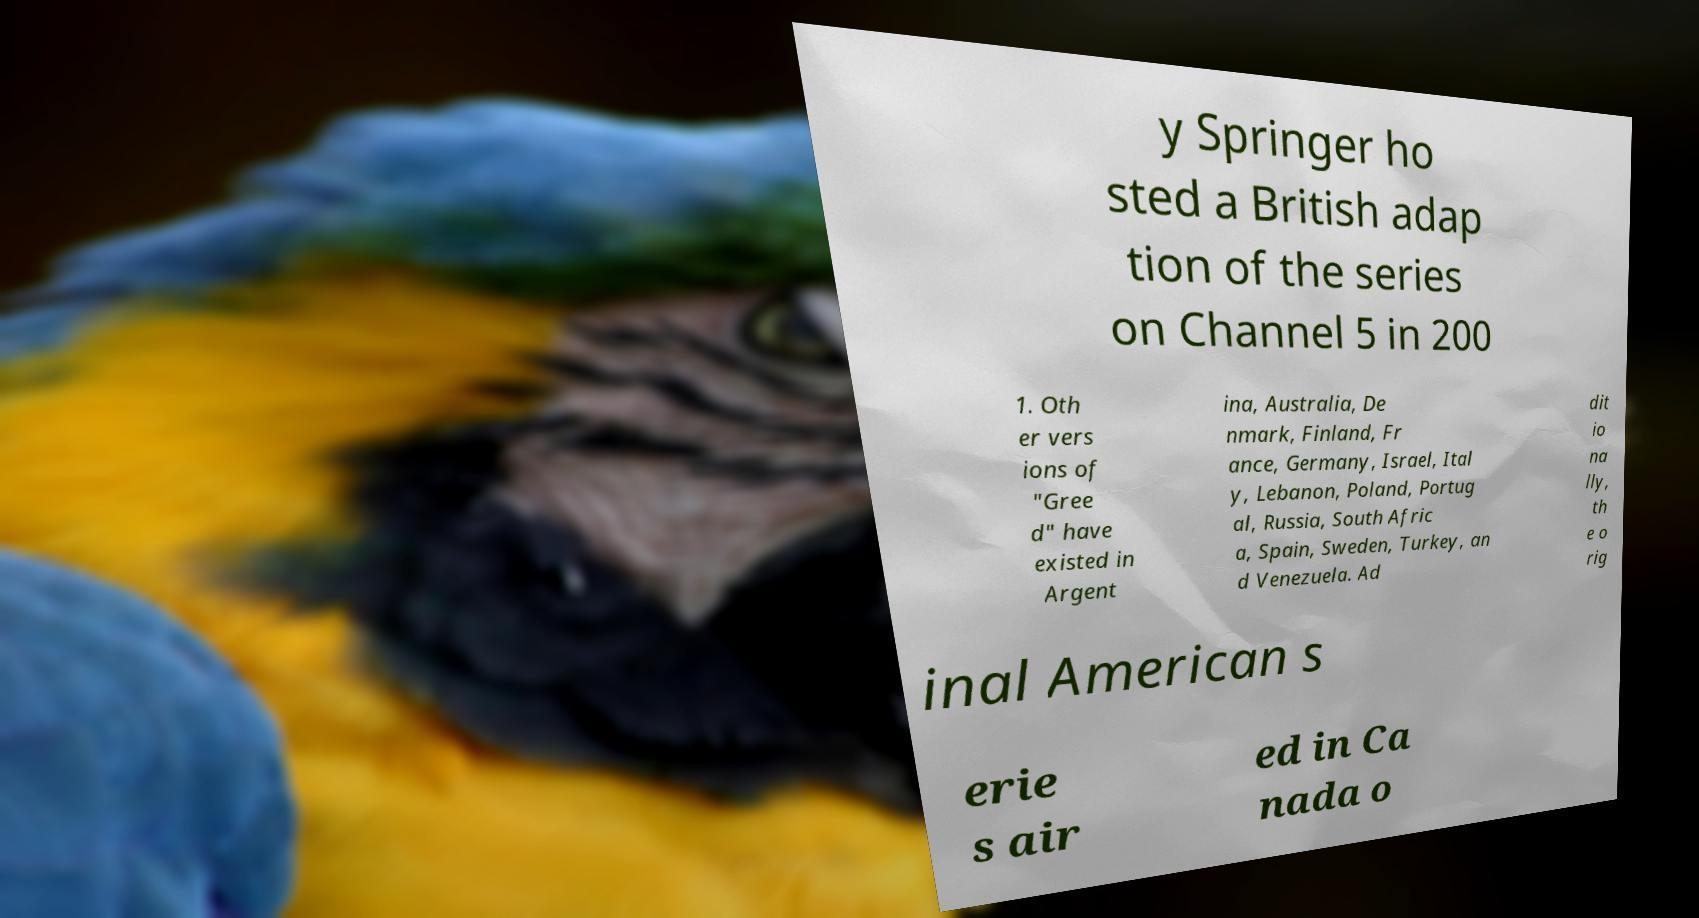What messages or text are displayed in this image? I need them in a readable, typed format. y Springer ho sted a British adap tion of the series on Channel 5 in 200 1. Oth er vers ions of "Gree d" have existed in Argent ina, Australia, De nmark, Finland, Fr ance, Germany, Israel, Ital y, Lebanon, Poland, Portug al, Russia, South Afric a, Spain, Sweden, Turkey, an d Venezuela. Ad dit io na lly, th e o rig inal American s erie s air ed in Ca nada o 